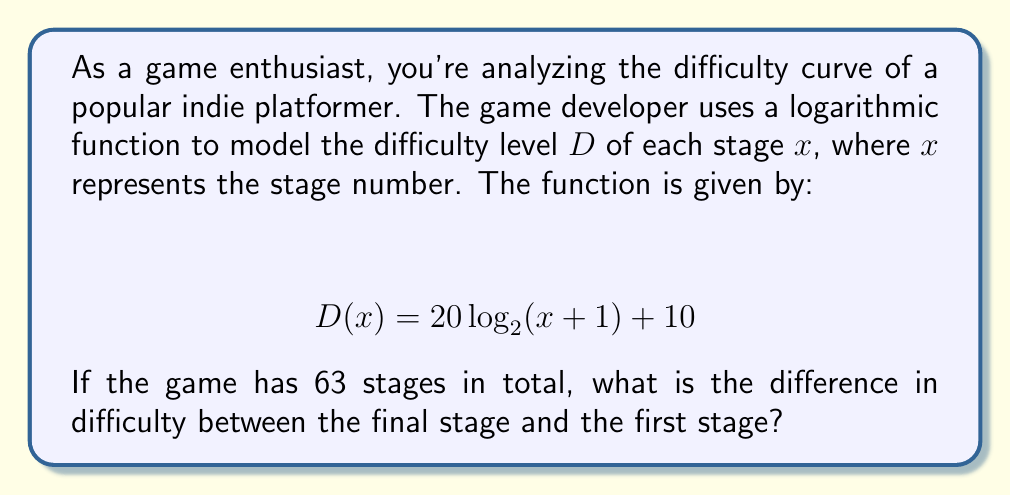Show me your answer to this math problem. To solve this problem, we need to follow these steps:

1) First, let's calculate the difficulty of the first stage (x = 1):
   $$ D(1) = 20 \log_2(1 + 1) + 10 $$
   $$ D(1) = 20 \log_2(2) + 10 $$
   $$ D(1) = 20 \cdot 1 + 10 = 30 $$

2) Now, let's calculate the difficulty of the final stage (x = 63):
   $$ D(63) = 20 \log_2(63 + 1) + 10 $$
   $$ D(63) = 20 \log_2(64) + 10 $$
   $$ D(63) = 20 \cdot 6 + 10 = 130 $$

3) To find the difference in difficulty, we subtract the difficulty of the first stage from the difficulty of the final stage:
   $$ \text{Difference} = D(63) - D(1) = 130 - 30 = 100 $$

Therefore, the difference in difficulty between the final stage and the first stage is 100 units.
Answer: 100 